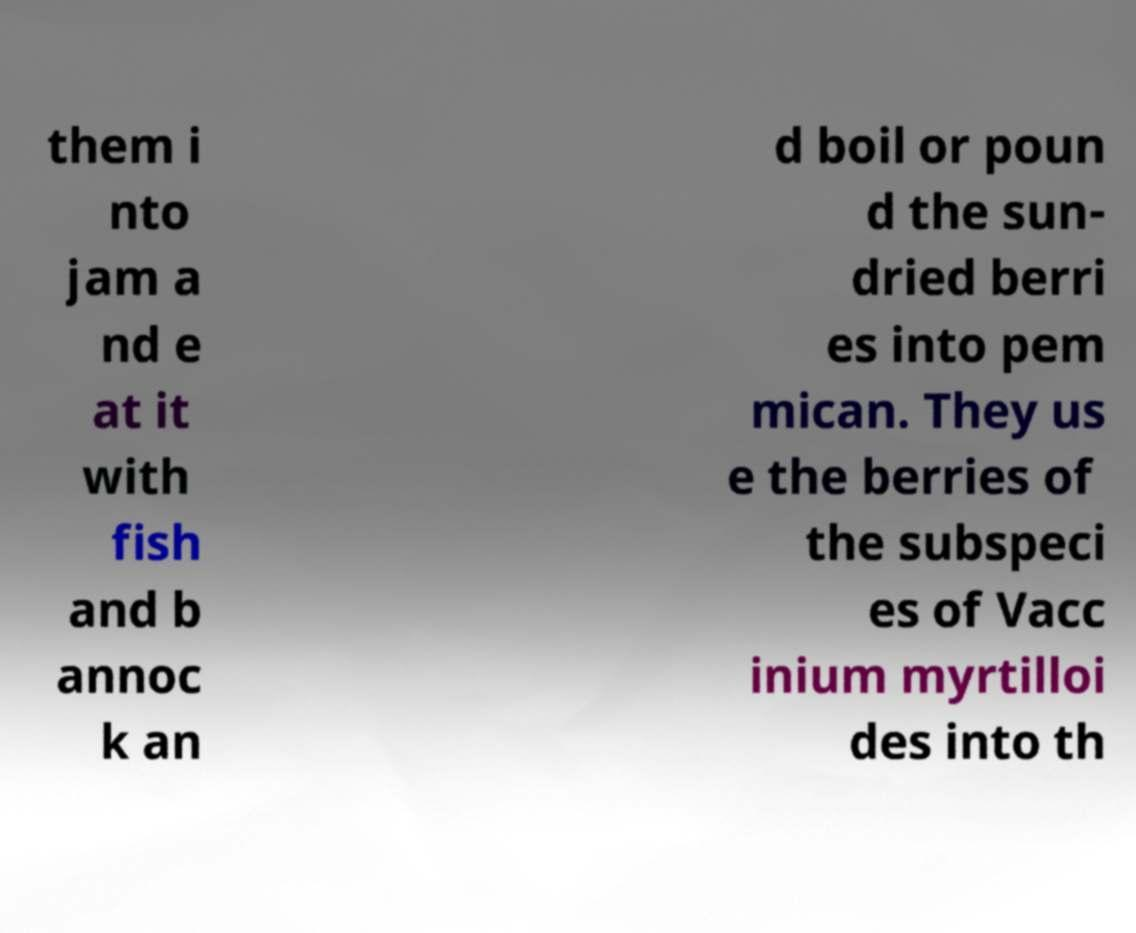I need the written content from this picture converted into text. Can you do that? them i nto jam a nd e at it with fish and b annoc k an d boil or poun d the sun- dried berri es into pem mican. They us e the berries of the subspeci es of Vacc inium myrtilloi des into th 